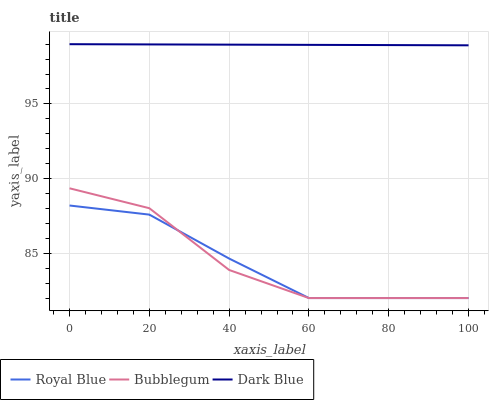Does Royal Blue have the minimum area under the curve?
Answer yes or no. Yes. Does Dark Blue have the maximum area under the curve?
Answer yes or no. Yes. Does Bubblegum have the minimum area under the curve?
Answer yes or no. No. Does Bubblegum have the maximum area under the curve?
Answer yes or no. No. Is Dark Blue the smoothest?
Answer yes or no. Yes. Is Bubblegum the roughest?
Answer yes or no. Yes. Is Bubblegum the smoothest?
Answer yes or no. No. Is Dark Blue the roughest?
Answer yes or no. No. Does Royal Blue have the lowest value?
Answer yes or no. Yes. Does Dark Blue have the lowest value?
Answer yes or no. No. Does Dark Blue have the highest value?
Answer yes or no. Yes. Does Bubblegum have the highest value?
Answer yes or no. No. Is Bubblegum less than Dark Blue?
Answer yes or no. Yes. Is Dark Blue greater than Bubblegum?
Answer yes or no. Yes. Does Royal Blue intersect Bubblegum?
Answer yes or no. Yes. Is Royal Blue less than Bubblegum?
Answer yes or no. No. Is Royal Blue greater than Bubblegum?
Answer yes or no. No. Does Bubblegum intersect Dark Blue?
Answer yes or no. No. 